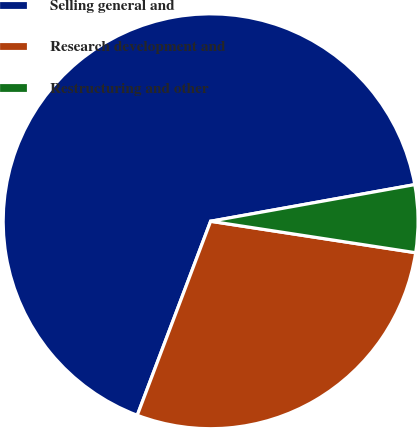<chart> <loc_0><loc_0><loc_500><loc_500><pie_chart><fcel>Selling general and<fcel>Research development and<fcel>Restructuring and other<nl><fcel>66.42%<fcel>28.33%<fcel>5.25%<nl></chart> 